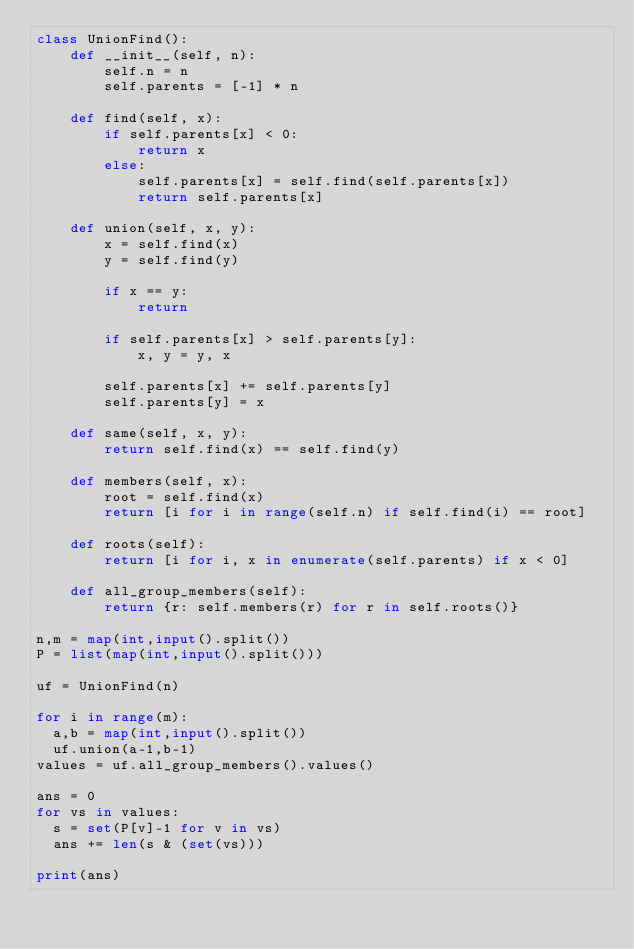<code> <loc_0><loc_0><loc_500><loc_500><_Python_>class UnionFind():
    def __init__(self, n):
        self.n = n
        self.parents = [-1] * n

    def find(self, x):
        if self.parents[x] < 0:
            return x
        else:
            self.parents[x] = self.find(self.parents[x])
            return self.parents[x]

    def union(self, x, y):
        x = self.find(x)
        y = self.find(y)

        if x == y:
            return

        if self.parents[x] > self.parents[y]:
            x, y = y, x

        self.parents[x] += self.parents[y]
        self.parents[y] = x
    
    def same(self, x, y):
        return self.find(x) == self.find(y)

    def members(self, x):
        root = self.find(x)
        return [i for i in range(self.n) if self.find(i) == root]      

    def roots(self):
        return [i for i, x in enumerate(self.parents) if x < 0]      
      
    def all_group_members(self):
        return {r: self.members(r) for r in self.roots()}
      
n,m = map(int,input().split())
P = list(map(int,input().split()))

uf = UnionFind(n)

for i in range(m):
  a,b = map(int,input().split())
  uf.union(a-1,b-1)
values = uf.all_group_members().values()

ans = 0
for vs in values:
  s = set(P[v]-1 for v in vs)
  ans += len(s & (set(vs)))

print(ans)  </code> 